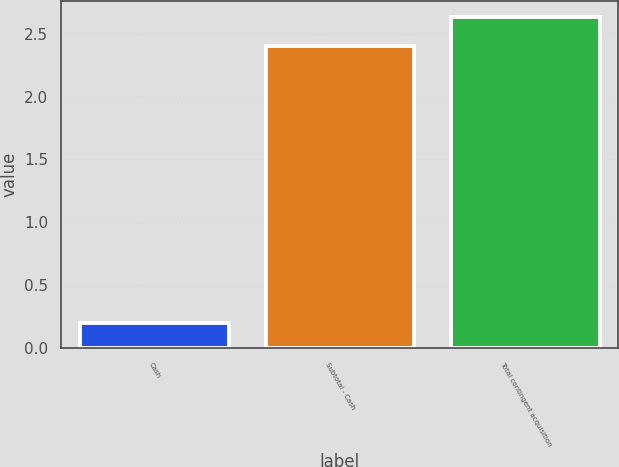<chart> <loc_0><loc_0><loc_500><loc_500><bar_chart><fcel>Cash<fcel>Subtotal - Cash<fcel>Total contingent acquisition<nl><fcel>0.2<fcel>2.4<fcel>2.63<nl></chart> 